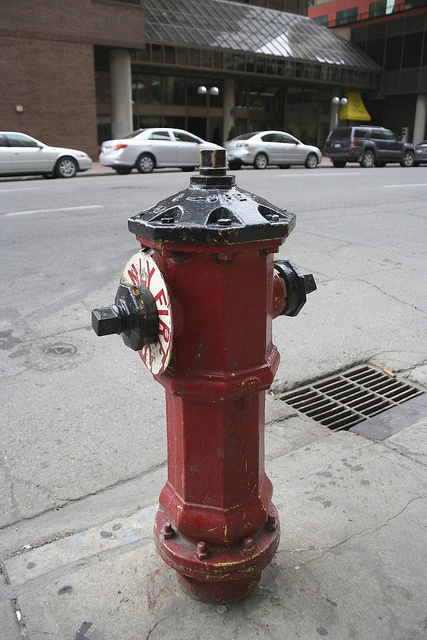Describe the objects in this image and their specific colors. I can see fire hydrant in black, maroon, gray, and brown tones, car in black, darkgray, white, and gray tones, car in black, gray, and darkgray tones, car in black, darkgray, lightgray, and gray tones, and car in black, darkgray, white, and gray tones in this image. 